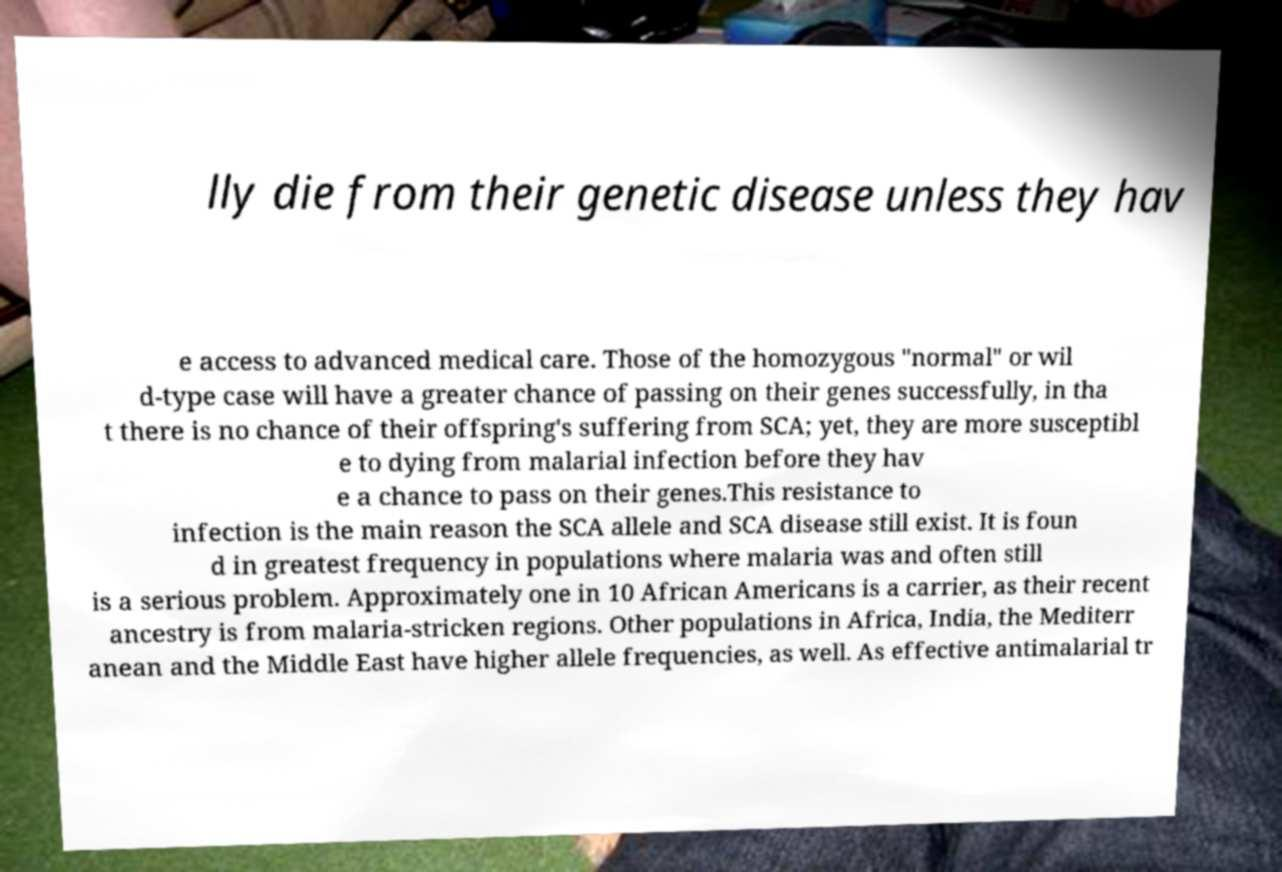Can you accurately transcribe the text from the provided image for me? lly die from their genetic disease unless they hav e access to advanced medical care. Those of the homozygous "normal" or wil d-type case will have a greater chance of passing on their genes successfully, in tha t there is no chance of their offspring's suffering from SCA; yet, they are more susceptibl e to dying from malarial infection before they hav e a chance to pass on their genes.This resistance to infection is the main reason the SCA allele and SCA disease still exist. It is foun d in greatest frequency in populations where malaria was and often still is a serious problem. Approximately one in 10 African Americans is a carrier, as their recent ancestry is from malaria-stricken regions. Other populations in Africa, India, the Mediterr anean and the Middle East have higher allele frequencies, as well. As effective antimalarial tr 